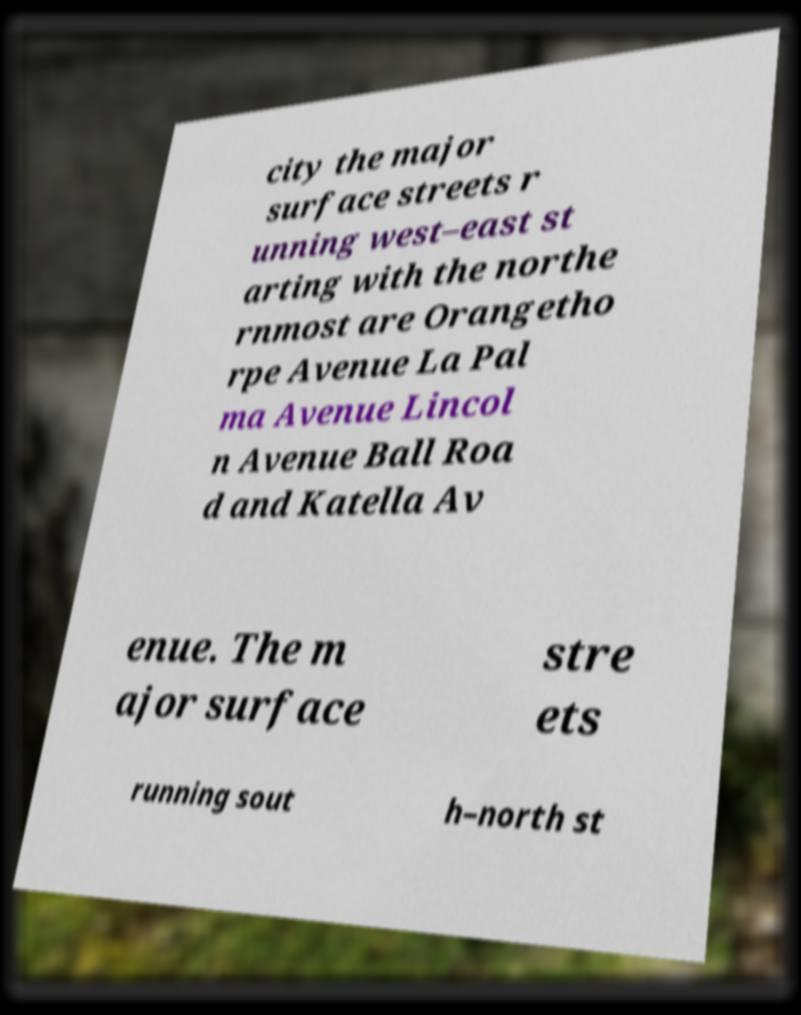What messages or text are displayed in this image? I need them in a readable, typed format. city the major surface streets r unning west–east st arting with the northe rnmost are Orangetho rpe Avenue La Pal ma Avenue Lincol n Avenue Ball Roa d and Katella Av enue. The m ajor surface stre ets running sout h–north st 